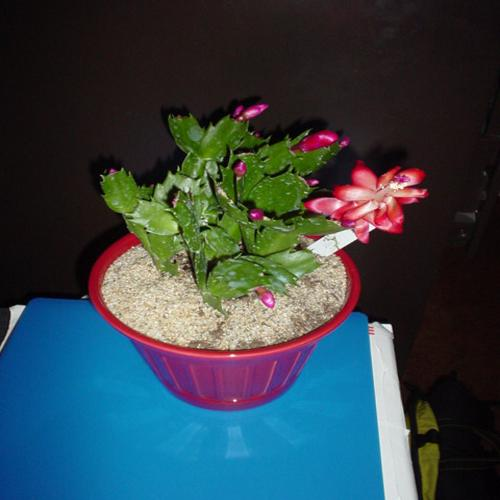What is the subject of the image?
A. A potted cactus.
B. A hanging basket.
C. A succulent plant.
D. A flowering plant.
Answer with the option's letter from the given choices directly.
 A. 